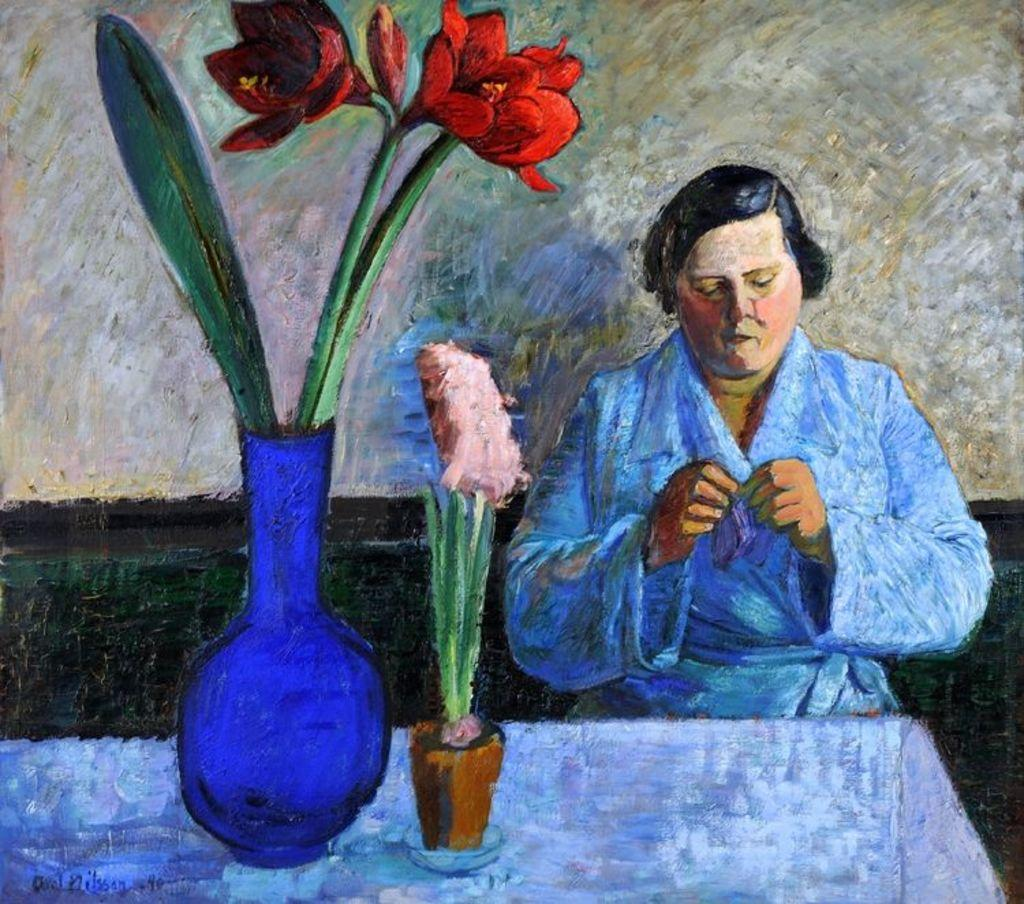What is depicted in the painting in the image? There is a painting of a person in the image. What piece of furniture is present in the image? There is a table in the image. What is on the table in the image? There is a flower pot and an object on the table. What can be seen behind the table in the image? There is a wall visible in the image. What type of support can be seen holding up the painting in the image? There is no visible support holding up the painting in the image. What type of kettle is present on the table in the image? There is no kettle present on the table in the image. 